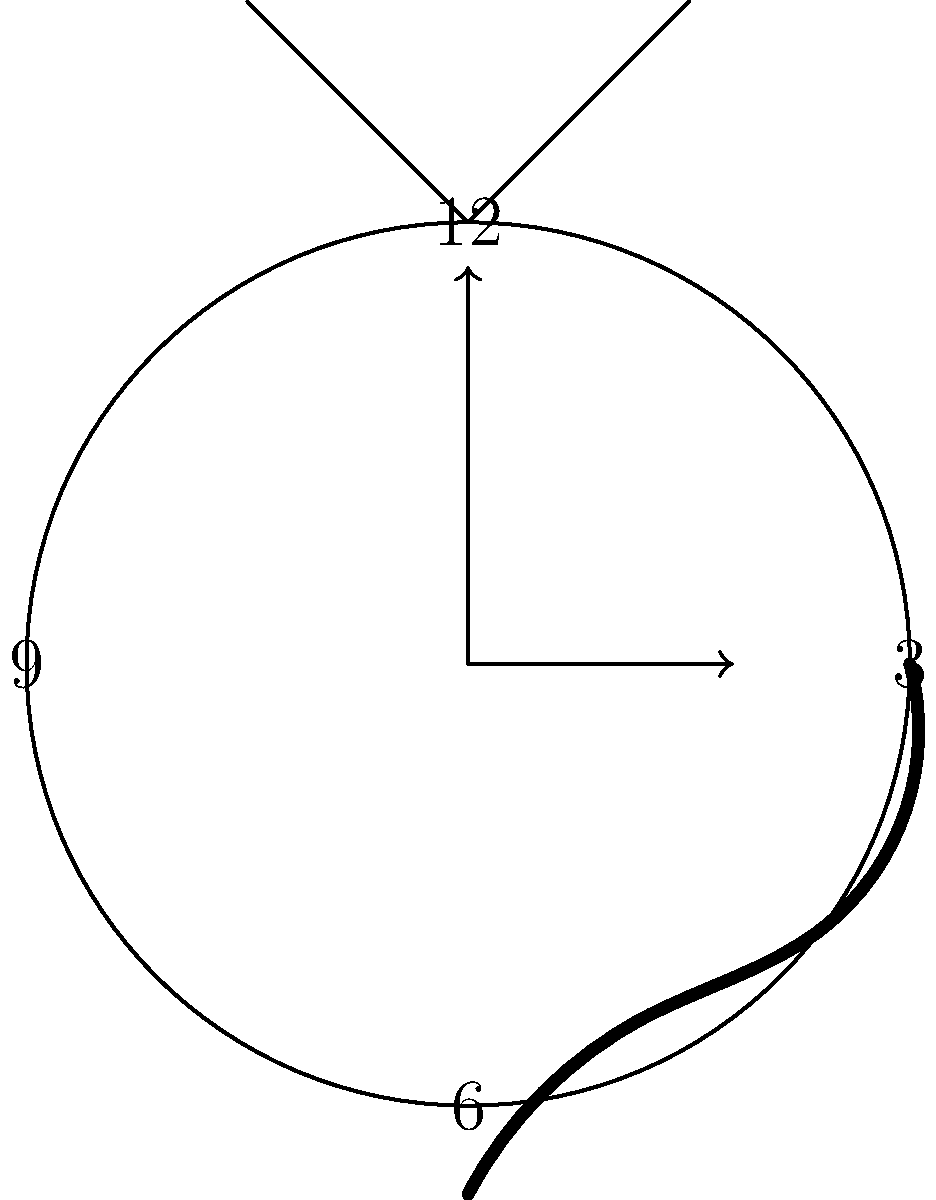In this surrealist painting inspired by Salvador Dali's "The Persistence of Memory," what philosophical concept is most prominently represented by the melting clock merged with a tree? To interpret this surrealist image, let's break it down step-by-step:

1. The central element is a clock, which typically represents time or the passage of time.

2. The clock is melting and distorted, reminiscent of Dali's famous melting clocks. This suggests a fluid or malleable perception of time.

3. The clock is merged with a tree, as evidenced by the branches growing from its top. Trees are often symbols of life, growth, and nature.

4. The combination of a man-made object (clock) with a natural element (tree) creates a juxtaposition between the artificial construct of time and the natural world.

5. The melting aspect of the clock implies a breakdown or distortion of our conventional understanding of time.

6. In philosophy, the concept of time as a rigid, linear construct is often challenged. The image suggests a more fluid, organic understanding of time.

7. This representation aligns with the philosophical concept of the subjective nature of time, where time is perceived differently based on individual experience or consciousness.

Given these elements, the philosophical concept most prominently represented is the subjective or relative nature of time. This image challenges our conventional understanding of time as an objective, fixed entity and instead presents it as something fluid, organic, and intertwined with nature and consciousness.
Answer: Subjective nature of time 